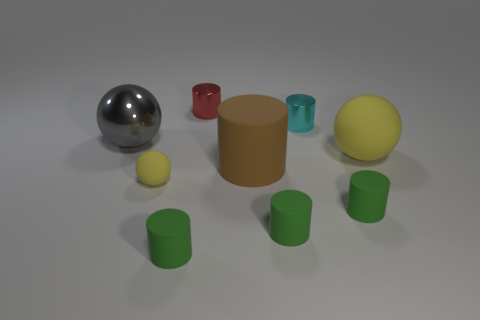Subtract all cyan balls. How many green cylinders are left? 3 Subtract all brown rubber cylinders. How many cylinders are left? 5 Subtract all red cylinders. How many cylinders are left? 5 Add 1 tiny cyan cylinders. How many objects exist? 10 Subtract all purple cylinders. Subtract all red balls. How many cylinders are left? 6 Subtract all balls. How many objects are left? 6 Subtract 0 yellow cylinders. How many objects are left? 9 Subtract all big green rubber blocks. Subtract all brown matte cylinders. How many objects are left? 8 Add 3 large gray metallic balls. How many large gray metallic balls are left? 4 Add 6 red shiny objects. How many red shiny objects exist? 7 